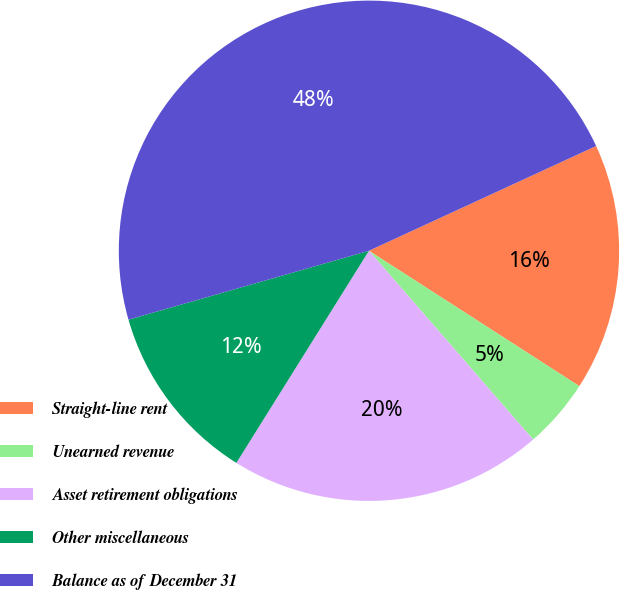<chart> <loc_0><loc_0><loc_500><loc_500><pie_chart><fcel>Straight-line rent<fcel>Unearned revenue<fcel>Asset retirement obligations<fcel>Other miscellaneous<fcel>Balance as of December 31<nl><fcel>15.98%<fcel>4.51%<fcel>20.28%<fcel>11.67%<fcel>47.57%<nl></chart> 